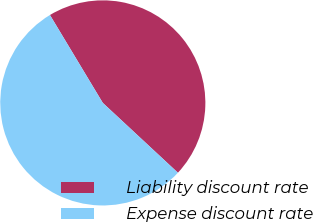<chart> <loc_0><loc_0><loc_500><loc_500><pie_chart><fcel>Liability discount rate<fcel>Expense discount rate<nl><fcel>45.54%<fcel>54.46%<nl></chart> 